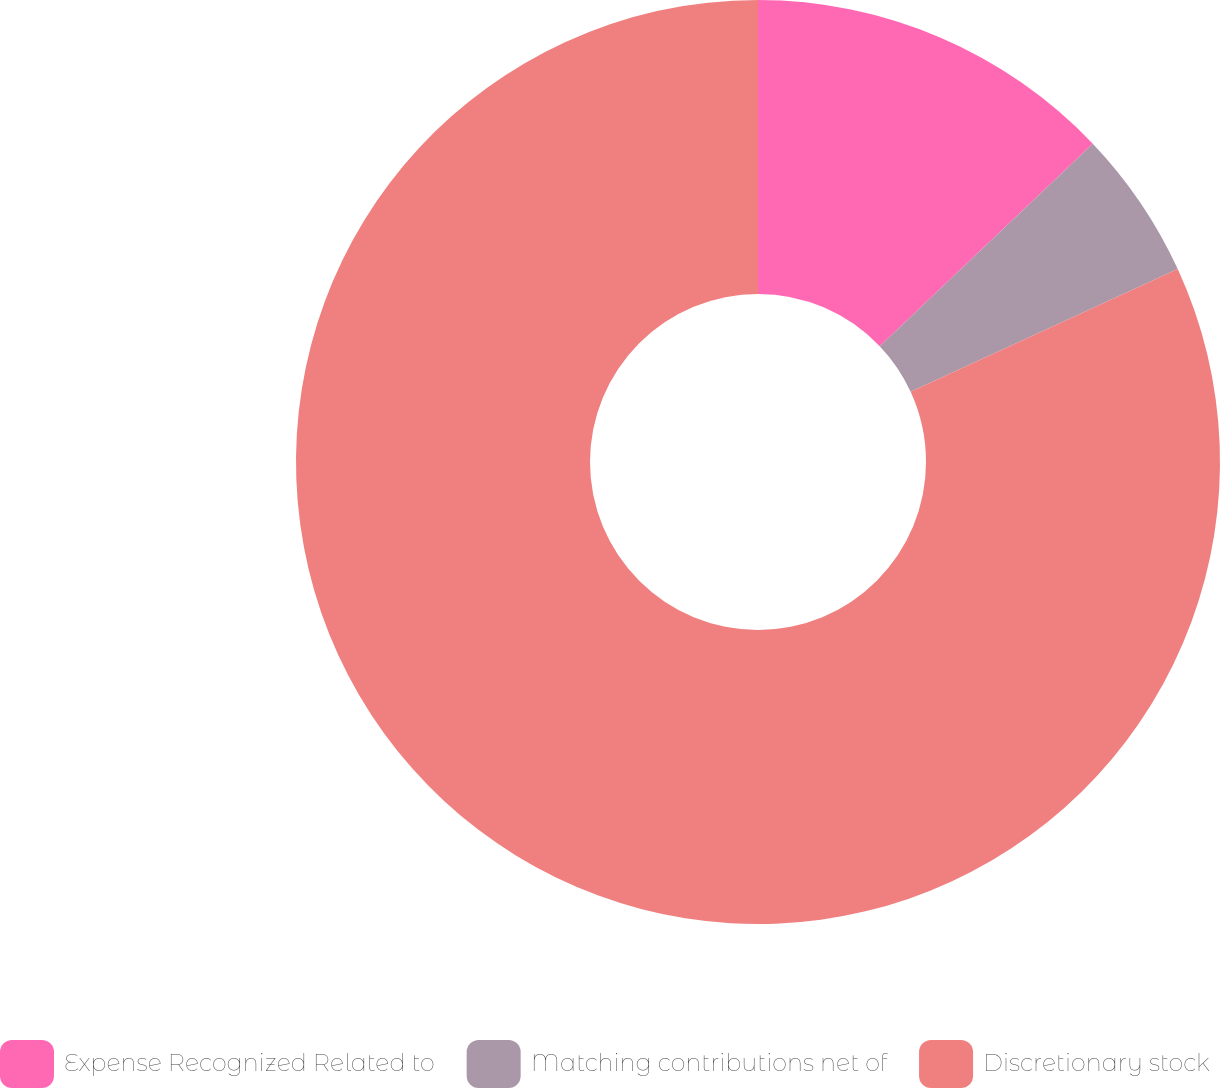Convert chart. <chart><loc_0><loc_0><loc_500><loc_500><pie_chart><fcel>Expense Recognized Related to<fcel>Matching contributions net of<fcel>Discretionary stock<nl><fcel>12.9%<fcel>5.24%<fcel>81.86%<nl></chart> 